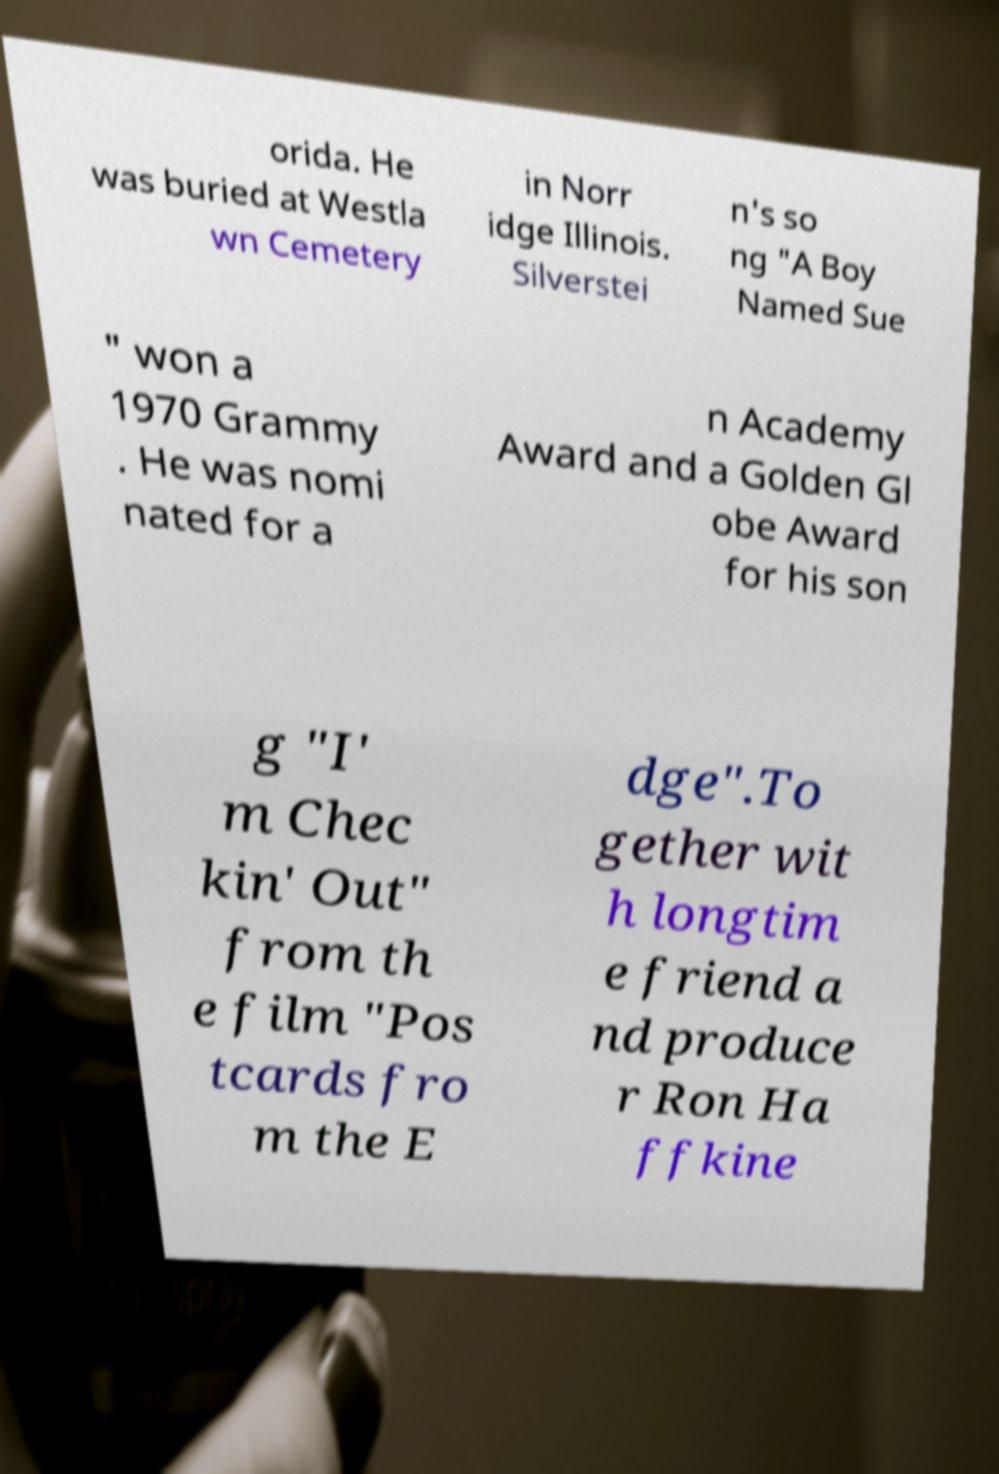Please identify and transcribe the text found in this image. orida. He was buried at Westla wn Cemetery in Norr idge Illinois. Silverstei n's so ng "A Boy Named Sue " won a 1970 Grammy . He was nomi nated for a n Academy Award and a Golden Gl obe Award for his son g "I' m Chec kin' Out" from th e film "Pos tcards fro m the E dge".To gether wit h longtim e friend a nd produce r Ron Ha ffkine 